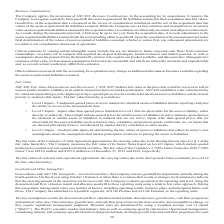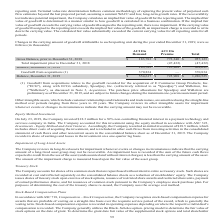According to Aci Worldwide's financial document, How did the company amortize other intangible assets? using the straight-line method over periods ranging from three years to 20 years.. The document states: "hips and trademarks and trade names, are amortized using the straight-line method over periods ranging from three years to 20 years. The Company revie..." Also, What was the balance of ACI On demand in 2019? According to the financial document, $554,617 (in thousands). The relevant text states: "Balance, December 31, 2019 $ 554,617 $ 725,908 $ 1,280,525..." Also, What was the total balance in 2019? According to the financial document, $1,280,525 (in thousands). The relevant text states: "Balance, December 31, 2019 $ 554,617 $ 725,908 $ 1,280,525..." Also, can you calculate: What was the change in balance of ACI on demand between 2018 and 2019? Based on the calculation: $554,617-183,783, the result is 370834 (in thousands). This is based on the information: "Gross Balance, prior to December 31, 2018 $ 183,783 $ 773,340 $ 957,123 Balance, December 31, 2019 $ 554,617 $ 725,908 $ 1,280,525..." The key data points involved are: 183,783, 554,617. Also, can you calculate: What was the change in total balance between 2018 and 2019? Based on the calculation: $1,280,525-909,691, the result is 370834 (in thousands). This is based on the information: "Balance, December 31, 2019 $ 554,617 $ 725,908 $ 1,280,525 Balance, December 31, 2018 183,783 725,908 909,691..." The key data points involved are: 1,280,525, 909,691. Also, can you calculate: What percentage of total balance consists of ACI on Demand in 2019? Based on the calculation: $554,617/$1,280,525, the result is 43.31 (percentage). This is based on the information: "Balance, December 31, 2019 $ 554,617 $ 725,908 $ 1,280,525 Balance, December 31, 2019 $ 554,617 $ 725,908 $ 1,280,525..." The key data points involved are: 1,280,525, 554,617. 